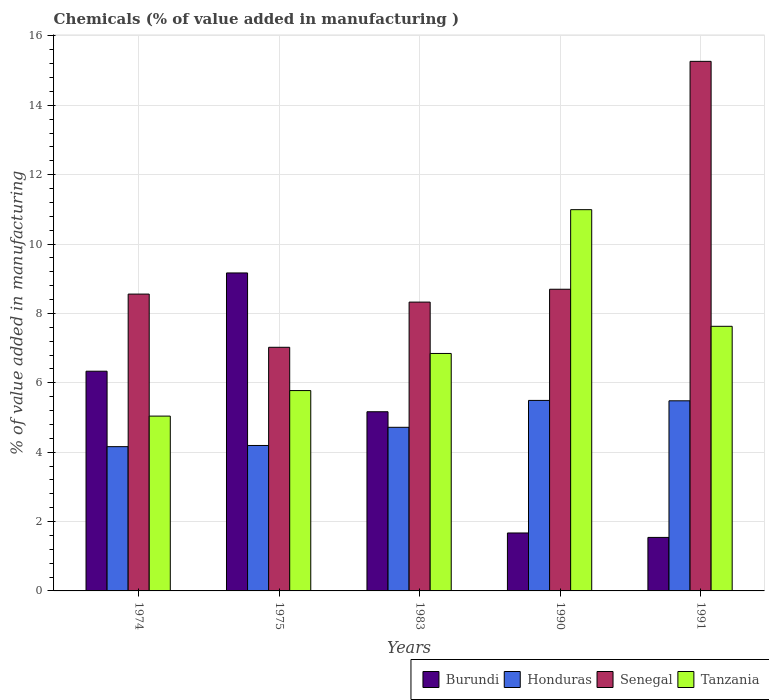How many different coloured bars are there?
Your response must be concise. 4. Are the number of bars per tick equal to the number of legend labels?
Provide a short and direct response. Yes. Are the number of bars on each tick of the X-axis equal?
Ensure brevity in your answer.  Yes. How many bars are there on the 5th tick from the left?
Your answer should be very brief. 4. What is the value added in manufacturing chemicals in Burundi in 1991?
Your answer should be compact. 1.54. Across all years, what is the maximum value added in manufacturing chemicals in Tanzania?
Your answer should be very brief. 10.99. Across all years, what is the minimum value added in manufacturing chemicals in Tanzania?
Make the answer very short. 5.04. In which year was the value added in manufacturing chemicals in Honduras maximum?
Ensure brevity in your answer.  1990. In which year was the value added in manufacturing chemicals in Honduras minimum?
Give a very brief answer. 1974. What is the total value added in manufacturing chemicals in Senegal in the graph?
Ensure brevity in your answer.  47.87. What is the difference between the value added in manufacturing chemicals in Burundi in 1974 and that in 1991?
Offer a terse response. 4.79. What is the difference between the value added in manufacturing chemicals in Tanzania in 1975 and the value added in manufacturing chemicals in Burundi in 1991?
Keep it short and to the point. 4.23. What is the average value added in manufacturing chemicals in Senegal per year?
Your answer should be very brief. 9.57. In the year 1990, what is the difference between the value added in manufacturing chemicals in Tanzania and value added in manufacturing chemicals in Honduras?
Your answer should be compact. 5.5. In how many years, is the value added in manufacturing chemicals in Senegal greater than 2.4 %?
Offer a terse response. 5. What is the ratio of the value added in manufacturing chemicals in Senegal in 1990 to that in 1991?
Your response must be concise. 0.57. Is the difference between the value added in manufacturing chemicals in Tanzania in 1974 and 1991 greater than the difference between the value added in manufacturing chemicals in Honduras in 1974 and 1991?
Keep it short and to the point. No. What is the difference between the highest and the second highest value added in manufacturing chemicals in Burundi?
Give a very brief answer. 2.83. What is the difference between the highest and the lowest value added in manufacturing chemicals in Honduras?
Offer a terse response. 1.33. What does the 2nd bar from the left in 1990 represents?
Ensure brevity in your answer.  Honduras. What does the 3rd bar from the right in 1991 represents?
Give a very brief answer. Honduras. How many bars are there?
Ensure brevity in your answer.  20. Are all the bars in the graph horizontal?
Give a very brief answer. No. How many years are there in the graph?
Make the answer very short. 5. Does the graph contain any zero values?
Your answer should be compact. No. Does the graph contain grids?
Offer a very short reply. Yes. Where does the legend appear in the graph?
Keep it short and to the point. Bottom right. How many legend labels are there?
Provide a succinct answer. 4. How are the legend labels stacked?
Give a very brief answer. Horizontal. What is the title of the graph?
Provide a succinct answer. Chemicals (% of value added in manufacturing ). Does "Malaysia" appear as one of the legend labels in the graph?
Provide a short and direct response. No. What is the label or title of the X-axis?
Your response must be concise. Years. What is the label or title of the Y-axis?
Offer a very short reply. % of value added in manufacturing. What is the % of value added in manufacturing in Burundi in 1974?
Make the answer very short. 6.33. What is the % of value added in manufacturing of Honduras in 1974?
Make the answer very short. 4.16. What is the % of value added in manufacturing of Senegal in 1974?
Make the answer very short. 8.56. What is the % of value added in manufacturing in Tanzania in 1974?
Your answer should be compact. 5.04. What is the % of value added in manufacturing of Burundi in 1975?
Provide a short and direct response. 9.17. What is the % of value added in manufacturing in Honduras in 1975?
Give a very brief answer. 4.19. What is the % of value added in manufacturing in Senegal in 1975?
Provide a short and direct response. 7.02. What is the % of value added in manufacturing of Tanzania in 1975?
Ensure brevity in your answer.  5.78. What is the % of value added in manufacturing in Burundi in 1983?
Your response must be concise. 5.17. What is the % of value added in manufacturing of Honduras in 1983?
Give a very brief answer. 4.72. What is the % of value added in manufacturing of Senegal in 1983?
Make the answer very short. 8.33. What is the % of value added in manufacturing of Tanzania in 1983?
Offer a very short reply. 6.85. What is the % of value added in manufacturing of Burundi in 1990?
Your answer should be very brief. 1.67. What is the % of value added in manufacturing in Honduras in 1990?
Make the answer very short. 5.49. What is the % of value added in manufacturing of Senegal in 1990?
Give a very brief answer. 8.7. What is the % of value added in manufacturing in Tanzania in 1990?
Ensure brevity in your answer.  10.99. What is the % of value added in manufacturing in Burundi in 1991?
Offer a terse response. 1.54. What is the % of value added in manufacturing in Honduras in 1991?
Provide a succinct answer. 5.48. What is the % of value added in manufacturing of Senegal in 1991?
Your response must be concise. 15.27. What is the % of value added in manufacturing in Tanzania in 1991?
Your response must be concise. 7.63. Across all years, what is the maximum % of value added in manufacturing of Burundi?
Your answer should be very brief. 9.17. Across all years, what is the maximum % of value added in manufacturing in Honduras?
Provide a short and direct response. 5.49. Across all years, what is the maximum % of value added in manufacturing in Senegal?
Make the answer very short. 15.27. Across all years, what is the maximum % of value added in manufacturing of Tanzania?
Make the answer very short. 10.99. Across all years, what is the minimum % of value added in manufacturing of Burundi?
Ensure brevity in your answer.  1.54. Across all years, what is the minimum % of value added in manufacturing of Honduras?
Give a very brief answer. 4.16. Across all years, what is the minimum % of value added in manufacturing of Senegal?
Offer a very short reply. 7.02. Across all years, what is the minimum % of value added in manufacturing in Tanzania?
Your answer should be compact. 5.04. What is the total % of value added in manufacturing in Burundi in the graph?
Keep it short and to the point. 23.88. What is the total % of value added in manufacturing of Honduras in the graph?
Ensure brevity in your answer.  24.04. What is the total % of value added in manufacturing in Senegal in the graph?
Ensure brevity in your answer.  47.87. What is the total % of value added in manufacturing of Tanzania in the graph?
Provide a succinct answer. 36.28. What is the difference between the % of value added in manufacturing of Burundi in 1974 and that in 1975?
Your answer should be compact. -2.83. What is the difference between the % of value added in manufacturing in Honduras in 1974 and that in 1975?
Provide a succinct answer. -0.03. What is the difference between the % of value added in manufacturing of Senegal in 1974 and that in 1975?
Provide a succinct answer. 1.53. What is the difference between the % of value added in manufacturing in Tanzania in 1974 and that in 1975?
Your answer should be very brief. -0.74. What is the difference between the % of value added in manufacturing in Burundi in 1974 and that in 1983?
Offer a very short reply. 1.17. What is the difference between the % of value added in manufacturing in Honduras in 1974 and that in 1983?
Give a very brief answer. -0.56. What is the difference between the % of value added in manufacturing of Senegal in 1974 and that in 1983?
Your response must be concise. 0.23. What is the difference between the % of value added in manufacturing of Tanzania in 1974 and that in 1983?
Your response must be concise. -1.81. What is the difference between the % of value added in manufacturing in Burundi in 1974 and that in 1990?
Ensure brevity in your answer.  4.66. What is the difference between the % of value added in manufacturing in Honduras in 1974 and that in 1990?
Keep it short and to the point. -1.33. What is the difference between the % of value added in manufacturing of Senegal in 1974 and that in 1990?
Make the answer very short. -0.14. What is the difference between the % of value added in manufacturing of Tanzania in 1974 and that in 1990?
Offer a very short reply. -5.95. What is the difference between the % of value added in manufacturing of Burundi in 1974 and that in 1991?
Your answer should be very brief. 4.79. What is the difference between the % of value added in manufacturing in Honduras in 1974 and that in 1991?
Make the answer very short. -1.32. What is the difference between the % of value added in manufacturing in Senegal in 1974 and that in 1991?
Provide a short and direct response. -6.71. What is the difference between the % of value added in manufacturing in Tanzania in 1974 and that in 1991?
Your answer should be compact. -2.59. What is the difference between the % of value added in manufacturing in Burundi in 1975 and that in 1983?
Your answer should be compact. 4. What is the difference between the % of value added in manufacturing of Honduras in 1975 and that in 1983?
Provide a short and direct response. -0.52. What is the difference between the % of value added in manufacturing of Senegal in 1975 and that in 1983?
Give a very brief answer. -1.3. What is the difference between the % of value added in manufacturing of Tanzania in 1975 and that in 1983?
Offer a very short reply. -1.07. What is the difference between the % of value added in manufacturing of Burundi in 1975 and that in 1990?
Provide a short and direct response. 7.5. What is the difference between the % of value added in manufacturing in Honduras in 1975 and that in 1990?
Your answer should be very brief. -1.3. What is the difference between the % of value added in manufacturing in Senegal in 1975 and that in 1990?
Give a very brief answer. -1.67. What is the difference between the % of value added in manufacturing in Tanzania in 1975 and that in 1990?
Ensure brevity in your answer.  -5.22. What is the difference between the % of value added in manufacturing of Burundi in 1975 and that in 1991?
Your answer should be very brief. 7.62. What is the difference between the % of value added in manufacturing in Honduras in 1975 and that in 1991?
Ensure brevity in your answer.  -1.29. What is the difference between the % of value added in manufacturing in Senegal in 1975 and that in 1991?
Your answer should be very brief. -8.24. What is the difference between the % of value added in manufacturing of Tanzania in 1975 and that in 1991?
Your answer should be very brief. -1.85. What is the difference between the % of value added in manufacturing of Burundi in 1983 and that in 1990?
Your answer should be very brief. 3.49. What is the difference between the % of value added in manufacturing of Honduras in 1983 and that in 1990?
Make the answer very short. -0.78. What is the difference between the % of value added in manufacturing of Senegal in 1983 and that in 1990?
Ensure brevity in your answer.  -0.37. What is the difference between the % of value added in manufacturing of Tanzania in 1983 and that in 1990?
Ensure brevity in your answer.  -4.15. What is the difference between the % of value added in manufacturing of Burundi in 1983 and that in 1991?
Your response must be concise. 3.62. What is the difference between the % of value added in manufacturing in Honduras in 1983 and that in 1991?
Give a very brief answer. -0.76. What is the difference between the % of value added in manufacturing of Senegal in 1983 and that in 1991?
Keep it short and to the point. -6.94. What is the difference between the % of value added in manufacturing of Tanzania in 1983 and that in 1991?
Provide a short and direct response. -0.78. What is the difference between the % of value added in manufacturing in Burundi in 1990 and that in 1991?
Offer a very short reply. 0.13. What is the difference between the % of value added in manufacturing of Honduras in 1990 and that in 1991?
Give a very brief answer. 0.01. What is the difference between the % of value added in manufacturing in Senegal in 1990 and that in 1991?
Ensure brevity in your answer.  -6.57. What is the difference between the % of value added in manufacturing of Tanzania in 1990 and that in 1991?
Your response must be concise. 3.36. What is the difference between the % of value added in manufacturing of Burundi in 1974 and the % of value added in manufacturing of Honduras in 1975?
Provide a short and direct response. 2.14. What is the difference between the % of value added in manufacturing of Burundi in 1974 and the % of value added in manufacturing of Senegal in 1975?
Make the answer very short. -0.69. What is the difference between the % of value added in manufacturing in Burundi in 1974 and the % of value added in manufacturing in Tanzania in 1975?
Keep it short and to the point. 0.56. What is the difference between the % of value added in manufacturing in Honduras in 1974 and the % of value added in manufacturing in Senegal in 1975?
Offer a very short reply. -2.86. What is the difference between the % of value added in manufacturing in Honduras in 1974 and the % of value added in manufacturing in Tanzania in 1975?
Offer a terse response. -1.62. What is the difference between the % of value added in manufacturing of Senegal in 1974 and the % of value added in manufacturing of Tanzania in 1975?
Give a very brief answer. 2.78. What is the difference between the % of value added in manufacturing in Burundi in 1974 and the % of value added in manufacturing in Honduras in 1983?
Your answer should be very brief. 1.62. What is the difference between the % of value added in manufacturing in Burundi in 1974 and the % of value added in manufacturing in Senegal in 1983?
Keep it short and to the point. -1.99. What is the difference between the % of value added in manufacturing in Burundi in 1974 and the % of value added in manufacturing in Tanzania in 1983?
Offer a very short reply. -0.51. What is the difference between the % of value added in manufacturing of Honduras in 1974 and the % of value added in manufacturing of Senegal in 1983?
Provide a succinct answer. -4.17. What is the difference between the % of value added in manufacturing in Honduras in 1974 and the % of value added in manufacturing in Tanzania in 1983?
Give a very brief answer. -2.69. What is the difference between the % of value added in manufacturing of Senegal in 1974 and the % of value added in manufacturing of Tanzania in 1983?
Provide a succinct answer. 1.71. What is the difference between the % of value added in manufacturing of Burundi in 1974 and the % of value added in manufacturing of Honduras in 1990?
Provide a short and direct response. 0.84. What is the difference between the % of value added in manufacturing of Burundi in 1974 and the % of value added in manufacturing of Senegal in 1990?
Keep it short and to the point. -2.36. What is the difference between the % of value added in manufacturing in Burundi in 1974 and the % of value added in manufacturing in Tanzania in 1990?
Make the answer very short. -4.66. What is the difference between the % of value added in manufacturing in Honduras in 1974 and the % of value added in manufacturing in Senegal in 1990?
Ensure brevity in your answer.  -4.54. What is the difference between the % of value added in manufacturing of Honduras in 1974 and the % of value added in manufacturing of Tanzania in 1990?
Make the answer very short. -6.83. What is the difference between the % of value added in manufacturing of Senegal in 1974 and the % of value added in manufacturing of Tanzania in 1990?
Provide a succinct answer. -2.43. What is the difference between the % of value added in manufacturing in Burundi in 1974 and the % of value added in manufacturing in Honduras in 1991?
Make the answer very short. 0.85. What is the difference between the % of value added in manufacturing in Burundi in 1974 and the % of value added in manufacturing in Senegal in 1991?
Your answer should be very brief. -8.93. What is the difference between the % of value added in manufacturing of Burundi in 1974 and the % of value added in manufacturing of Tanzania in 1991?
Offer a very short reply. -1.29. What is the difference between the % of value added in manufacturing of Honduras in 1974 and the % of value added in manufacturing of Senegal in 1991?
Offer a terse response. -11.11. What is the difference between the % of value added in manufacturing of Honduras in 1974 and the % of value added in manufacturing of Tanzania in 1991?
Offer a terse response. -3.47. What is the difference between the % of value added in manufacturing in Senegal in 1974 and the % of value added in manufacturing in Tanzania in 1991?
Give a very brief answer. 0.93. What is the difference between the % of value added in manufacturing in Burundi in 1975 and the % of value added in manufacturing in Honduras in 1983?
Provide a succinct answer. 4.45. What is the difference between the % of value added in manufacturing in Burundi in 1975 and the % of value added in manufacturing in Senegal in 1983?
Provide a short and direct response. 0.84. What is the difference between the % of value added in manufacturing in Burundi in 1975 and the % of value added in manufacturing in Tanzania in 1983?
Your answer should be compact. 2.32. What is the difference between the % of value added in manufacturing in Honduras in 1975 and the % of value added in manufacturing in Senegal in 1983?
Provide a succinct answer. -4.13. What is the difference between the % of value added in manufacturing of Honduras in 1975 and the % of value added in manufacturing of Tanzania in 1983?
Provide a succinct answer. -2.65. What is the difference between the % of value added in manufacturing of Senegal in 1975 and the % of value added in manufacturing of Tanzania in 1983?
Make the answer very short. 0.18. What is the difference between the % of value added in manufacturing of Burundi in 1975 and the % of value added in manufacturing of Honduras in 1990?
Give a very brief answer. 3.67. What is the difference between the % of value added in manufacturing of Burundi in 1975 and the % of value added in manufacturing of Senegal in 1990?
Ensure brevity in your answer.  0.47. What is the difference between the % of value added in manufacturing of Burundi in 1975 and the % of value added in manufacturing of Tanzania in 1990?
Make the answer very short. -1.82. What is the difference between the % of value added in manufacturing in Honduras in 1975 and the % of value added in manufacturing in Senegal in 1990?
Make the answer very short. -4.5. What is the difference between the % of value added in manufacturing of Honduras in 1975 and the % of value added in manufacturing of Tanzania in 1990?
Ensure brevity in your answer.  -6.8. What is the difference between the % of value added in manufacturing of Senegal in 1975 and the % of value added in manufacturing of Tanzania in 1990?
Your answer should be compact. -3.97. What is the difference between the % of value added in manufacturing in Burundi in 1975 and the % of value added in manufacturing in Honduras in 1991?
Your answer should be very brief. 3.69. What is the difference between the % of value added in manufacturing in Burundi in 1975 and the % of value added in manufacturing in Senegal in 1991?
Give a very brief answer. -6.1. What is the difference between the % of value added in manufacturing in Burundi in 1975 and the % of value added in manufacturing in Tanzania in 1991?
Give a very brief answer. 1.54. What is the difference between the % of value added in manufacturing in Honduras in 1975 and the % of value added in manufacturing in Senegal in 1991?
Your answer should be compact. -11.07. What is the difference between the % of value added in manufacturing in Honduras in 1975 and the % of value added in manufacturing in Tanzania in 1991?
Provide a short and direct response. -3.44. What is the difference between the % of value added in manufacturing of Senegal in 1975 and the % of value added in manufacturing of Tanzania in 1991?
Provide a short and direct response. -0.6. What is the difference between the % of value added in manufacturing of Burundi in 1983 and the % of value added in manufacturing of Honduras in 1990?
Ensure brevity in your answer.  -0.33. What is the difference between the % of value added in manufacturing in Burundi in 1983 and the % of value added in manufacturing in Senegal in 1990?
Offer a terse response. -3.53. What is the difference between the % of value added in manufacturing of Burundi in 1983 and the % of value added in manufacturing of Tanzania in 1990?
Offer a very short reply. -5.83. What is the difference between the % of value added in manufacturing in Honduras in 1983 and the % of value added in manufacturing in Senegal in 1990?
Provide a succinct answer. -3.98. What is the difference between the % of value added in manufacturing of Honduras in 1983 and the % of value added in manufacturing of Tanzania in 1990?
Your response must be concise. -6.27. What is the difference between the % of value added in manufacturing of Senegal in 1983 and the % of value added in manufacturing of Tanzania in 1990?
Your response must be concise. -2.66. What is the difference between the % of value added in manufacturing in Burundi in 1983 and the % of value added in manufacturing in Honduras in 1991?
Ensure brevity in your answer.  -0.32. What is the difference between the % of value added in manufacturing of Burundi in 1983 and the % of value added in manufacturing of Senegal in 1991?
Keep it short and to the point. -10.1. What is the difference between the % of value added in manufacturing in Burundi in 1983 and the % of value added in manufacturing in Tanzania in 1991?
Give a very brief answer. -2.46. What is the difference between the % of value added in manufacturing of Honduras in 1983 and the % of value added in manufacturing of Senegal in 1991?
Offer a terse response. -10.55. What is the difference between the % of value added in manufacturing of Honduras in 1983 and the % of value added in manufacturing of Tanzania in 1991?
Your answer should be very brief. -2.91. What is the difference between the % of value added in manufacturing in Senegal in 1983 and the % of value added in manufacturing in Tanzania in 1991?
Provide a succinct answer. 0.7. What is the difference between the % of value added in manufacturing in Burundi in 1990 and the % of value added in manufacturing in Honduras in 1991?
Provide a succinct answer. -3.81. What is the difference between the % of value added in manufacturing in Burundi in 1990 and the % of value added in manufacturing in Senegal in 1991?
Give a very brief answer. -13.6. What is the difference between the % of value added in manufacturing of Burundi in 1990 and the % of value added in manufacturing of Tanzania in 1991?
Make the answer very short. -5.96. What is the difference between the % of value added in manufacturing in Honduras in 1990 and the % of value added in manufacturing in Senegal in 1991?
Keep it short and to the point. -9.77. What is the difference between the % of value added in manufacturing of Honduras in 1990 and the % of value added in manufacturing of Tanzania in 1991?
Your answer should be very brief. -2.14. What is the difference between the % of value added in manufacturing in Senegal in 1990 and the % of value added in manufacturing in Tanzania in 1991?
Ensure brevity in your answer.  1.07. What is the average % of value added in manufacturing of Burundi per year?
Offer a terse response. 4.78. What is the average % of value added in manufacturing of Honduras per year?
Provide a succinct answer. 4.81. What is the average % of value added in manufacturing in Senegal per year?
Offer a very short reply. 9.57. What is the average % of value added in manufacturing in Tanzania per year?
Offer a terse response. 7.26. In the year 1974, what is the difference between the % of value added in manufacturing in Burundi and % of value added in manufacturing in Honduras?
Make the answer very short. 2.17. In the year 1974, what is the difference between the % of value added in manufacturing of Burundi and % of value added in manufacturing of Senegal?
Provide a succinct answer. -2.22. In the year 1974, what is the difference between the % of value added in manufacturing of Burundi and % of value added in manufacturing of Tanzania?
Offer a very short reply. 1.29. In the year 1974, what is the difference between the % of value added in manufacturing of Honduras and % of value added in manufacturing of Senegal?
Provide a succinct answer. -4.4. In the year 1974, what is the difference between the % of value added in manufacturing of Honduras and % of value added in manufacturing of Tanzania?
Give a very brief answer. -0.88. In the year 1974, what is the difference between the % of value added in manufacturing of Senegal and % of value added in manufacturing of Tanzania?
Give a very brief answer. 3.52. In the year 1975, what is the difference between the % of value added in manufacturing of Burundi and % of value added in manufacturing of Honduras?
Offer a very short reply. 4.97. In the year 1975, what is the difference between the % of value added in manufacturing of Burundi and % of value added in manufacturing of Senegal?
Your answer should be very brief. 2.14. In the year 1975, what is the difference between the % of value added in manufacturing of Burundi and % of value added in manufacturing of Tanzania?
Provide a short and direct response. 3.39. In the year 1975, what is the difference between the % of value added in manufacturing of Honduras and % of value added in manufacturing of Senegal?
Make the answer very short. -2.83. In the year 1975, what is the difference between the % of value added in manufacturing in Honduras and % of value added in manufacturing in Tanzania?
Your answer should be compact. -1.58. In the year 1975, what is the difference between the % of value added in manufacturing in Senegal and % of value added in manufacturing in Tanzania?
Your response must be concise. 1.25. In the year 1983, what is the difference between the % of value added in manufacturing of Burundi and % of value added in manufacturing of Honduras?
Offer a very short reply. 0.45. In the year 1983, what is the difference between the % of value added in manufacturing in Burundi and % of value added in manufacturing in Senegal?
Make the answer very short. -3.16. In the year 1983, what is the difference between the % of value added in manufacturing in Burundi and % of value added in manufacturing in Tanzania?
Offer a terse response. -1.68. In the year 1983, what is the difference between the % of value added in manufacturing in Honduras and % of value added in manufacturing in Senegal?
Offer a very short reply. -3.61. In the year 1983, what is the difference between the % of value added in manufacturing in Honduras and % of value added in manufacturing in Tanzania?
Offer a terse response. -2.13. In the year 1983, what is the difference between the % of value added in manufacturing of Senegal and % of value added in manufacturing of Tanzania?
Provide a succinct answer. 1.48. In the year 1990, what is the difference between the % of value added in manufacturing in Burundi and % of value added in manufacturing in Honduras?
Offer a very short reply. -3.82. In the year 1990, what is the difference between the % of value added in manufacturing of Burundi and % of value added in manufacturing of Senegal?
Keep it short and to the point. -7.03. In the year 1990, what is the difference between the % of value added in manufacturing in Burundi and % of value added in manufacturing in Tanzania?
Your answer should be compact. -9.32. In the year 1990, what is the difference between the % of value added in manufacturing of Honduras and % of value added in manufacturing of Senegal?
Your answer should be very brief. -3.21. In the year 1990, what is the difference between the % of value added in manufacturing in Honduras and % of value added in manufacturing in Tanzania?
Your response must be concise. -5.5. In the year 1990, what is the difference between the % of value added in manufacturing in Senegal and % of value added in manufacturing in Tanzania?
Your answer should be compact. -2.29. In the year 1991, what is the difference between the % of value added in manufacturing in Burundi and % of value added in manufacturing in Honduras?
Provide a succinct answer. -3.94. In the year 1991, what is the difference between the % of value added in manufacturing in Burundi and % of value added in manufacturing in Senegal?
Provide a succinct answer. -13.72. In the year 1991, what is the difference between the % of value added in manufacturing in Burundi and % of value added in manufacturing in Tanzania?
Your answer should be very brief. -6.09. In the year 1991, what is the difference between the % of value added in manufacturing of Honduras and % of value added in manufacturing of Senegal?
Give a very brief answer. -9.79. In the year 1991, what is the difference between the % of value added in manufacturing of Honduras and % of value added in manufacturing of Tanzania?
Give a very brief answer. -2.15. In the year 1991, what is the difference between the % of value added in manufacturing of Senegal and % of value added in manufacturing of Tanzania?
Ensure brevity in your answer.  7.64. What is the ratio of the % of value added in manufacturing in Burundi in 1974 to that in 1975?
Give a very brief answer. 0.69. What is the ratio of the % of value added in manufacturing of Honduras in 1974 to that in 1975?
Offer a very short reply. 0.99. What is the ratio of the % of value added in manufacturing of Senegal in 1974 to that in 1975?
Give a very brief answer. 1.22. What is the ratio of the % of value added in manufacturing of Tanzania in 1974 to that in 1975?
Ensure brevity in your answer.  0.87. What is the ratio of the % of value added in manufacturing of Burundi in 1974 to that in 1983?
Give a very brief answer. 1.23. What is the ratio of the % of value added in manufacturing in Honduras in 1974 to that in 1983?
Ensure brevity in your answer.  0.88. What is the ratio of the % of value added in manufacturing in Senegal in 1974 to that in 1983?
Ensure brevity in your answer.  1.03. What is the ratio of the % of value added in manufacturing in Tanzania in 1974 to that in 1983?
Your response must be concise. 0.74. What is the ratio of the % of value added in manufacturing of Burundi in 1974 to that in 1990?
Ensure brevity in your answer.  3.79. What is the ratio of the % of value added in manufacturing in Honduras in 1974 to that in 1990?
Provide a short and direct response. 0.76. What is the ratio of the % of value added in manufacturing in Senegal in 1974 to that in 1990?
Offer a very short reply. 0.98. What is the ratio of the % of value added in manufacturing of Tanzania in 1974 to that in 1990?
Your answer should be compact. 0.46. What is the ratio of the % of value added in manufacturing of Burundi in 1974 to that in 1991?
Provide a succinct answer. 4.11. What is the ratio of the % of value added in manufacturing of Honduras in 1974 to that in 1991?
Offer a very short reply. 0.76. What is the ratio of the % of value added in manufacturing in Senegal in 1974 to that in 1991?
Offer a terse response. 0.56. What is the ratio of the % of value added in manufacturing in Tanzania in 1974 to that in 1991?
Make the answer very short. 0.66. What is the ratio of the % of value added in manufacturing in Burundi in 1975 to that in 1983?
Offer a very short reply. 1.77. What is the ratio of the % of value added in manufacturing in Honduras in 1975 to that in 1983?
Give a very brief answer. 0.89. What is the ratio of the % of value added in manufacturing in Senegal in 1975 to that in 1983?
Your response must be concise. 0.84. What is the ratio of the % of value added in manufacturing of Tanzania in 1975 to that in 1983?
Provide a short and direct response. 0.84. What is the ratio of the % of value added in manufacturing of Burundi in 1975 to that in 1990?
Offer a very short reply. 5.49. What is the ratio of the % of value added in manufacturing in Honduras in 1975 to that in 1990?
Ensure brevity in your answer.  0.76. What is the ratio of the % of value added in manufacturing in Senegal in 1975 to that in 1990?
Keep it short and to the point. 0.81. What is the ratio of the % of value added in manufacturing of Tanzania in 1975 to that in 1990?
Offer a terse response. 0.53. What is the ratio of the % of value added in manufacturing of Burundi in 1975 to that in 1991?
Give a very brief answer. 5.94. What is the ratio of the % of value added in manufacturing of Honduras in 1975 to that in 1991?
Give a very brief answer. 0.77. What is the ratio of the % of value added in manufacturing in Senegal in 1975 to that in 1991?
Make the answer very short. 0.46. What is the ratio of the % of value added in manufacturing in Tanzania in 1975 to that in 1991?
Ensure brevity in your answer.  0.76. What is the ratio of the % of value added in manufacturing of Burundi in 1983 to that in 1990?
Provide a short and direct response. 3.09. What is the ratio of the % of value added in manufacturing of Honduras in 1983 to that in 1990?
Offer a terse response. 0.86. What is the ratio of the % of value added in manufacturing of Senegal in 1983 to that in 1990?
Give a very brief answer. 0.96. What is the ratio of the % of value added in manufacturing in Tanzania in 1983 to that in 1990?
Make the answer very short. 0.62. What is the ratio of the % of value added in manufacturing in Burundi in 1983 to that in 1991?
Offer a very short reply. 3.35. What is the ratio of the % of value added in manufacturing in Honduras in 1983 to that in 1991?
Give a very brief answer. 0.86. What is the ratio of the % of value added in manufacturing in Senegal in 1983 to that in 1991?
Ensure brevity in your answer.  0.55. What is the ratio of the % of value added in manufacturing of Tanzania in 1983 to that in 1991?
Your response must be concise. 0.9. What is the ratio of the % of value added in manufacturing in Burundi in 1990 to that in 1991?
Your response must be concise. 1.08. What is the ratio of the % of value added in manufacturing of Senegal in 1990 to that in 1991?
Keep it short and to the point. 0.57. What is the ratio of the % of value added in manufacturing in Tanzania in 1990 to that in 1991?
Provide a succinct answer. 1.44. What is the difference between the highest and the second highest % of value added in manufacturing in Burundi?
Your answer should be very brief. 2.83. What is the difference between the highest and the second highest % of value added in manufacturing of Honduras?
Keep it short and to the point. 0.01. What is the difference between the highest and the second highest % of value added in manufacturing in Senegal?
Provide a succinct answer. 6.57. What is the difference between the highest and the second highest % of value added in manufacturing of Tanzania?
Ensure brevity in your answer.  3.36. What is the difference between the highest and the lowest % of value added in manufacturing in Burundi?
Provide a short and direct response. 7.62. What is the difference between the highest and the lowest % of value added in manufacturing of Honduras?
Ensure brevity in your answer.  1.33. What is the difference between the highest and the lowest % of value added in manufacturing of Senegal?
Your answer should be very brief. 8.24. What is the difference between the highest and the lowest % of value added in manufacturing of Tanzania?
Give a very brief answer. 5.95. 